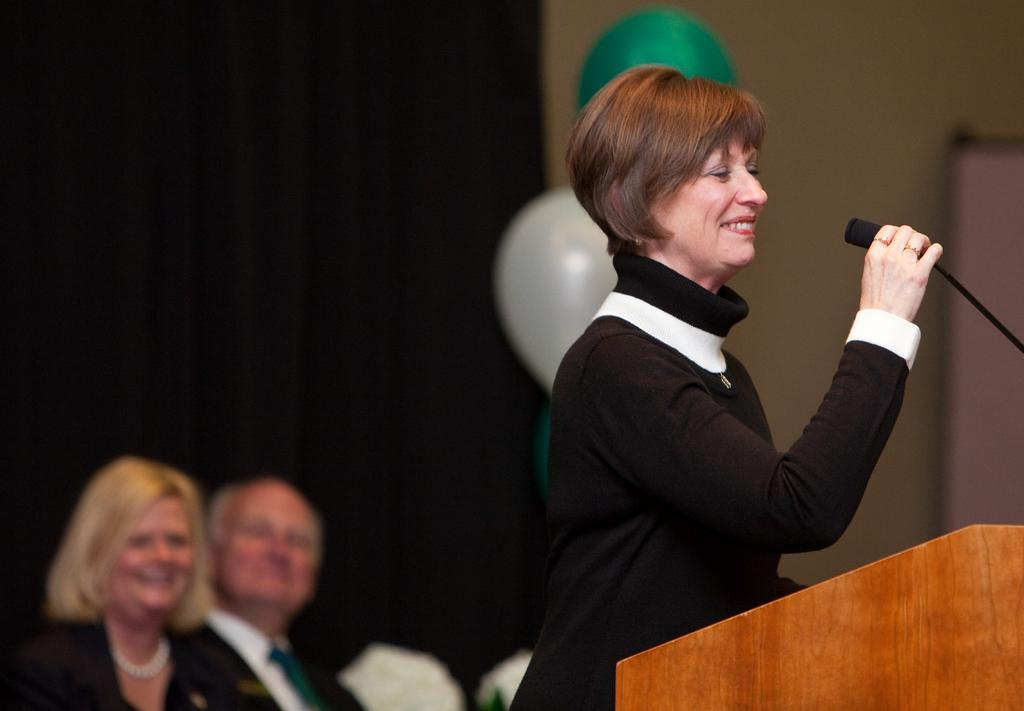Who is the main subject in the image? There is a woman in the image. What is the woman doing in the image? The woman is standing in front of a podium and holding a microphone. What can be seen in the background of the image? There are people, balloons, and other objects visible in the background of the image. What time is indicated by the hour on the podium in the image? There is no hour visible on the podium in the image. Can you see any flames in the image? There are no flames present in the image. 